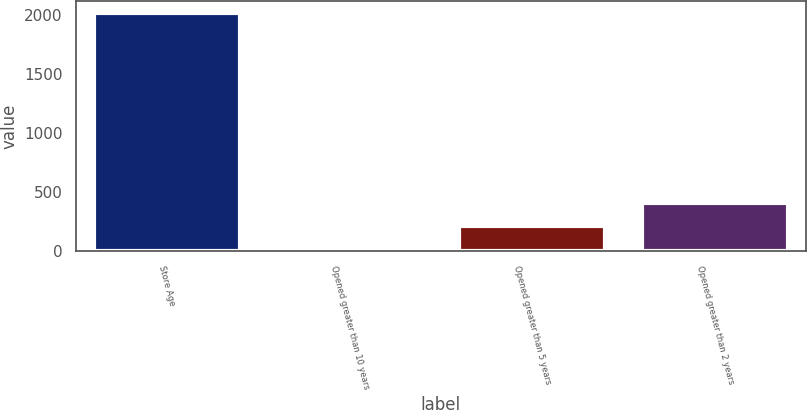Convert chart to OTSL. <chart><loc_0><loc_0><loc_500><loc_500><bar_chart><fcel>Store Age<fcel>Opened greater than 10 years<fcel>Opened greater than 5 years<fcel>Opened greater than 2 years<nl><fcel>2014<fcel>10.5<fcel>210.85<fcel>411.2<nl></chart> 